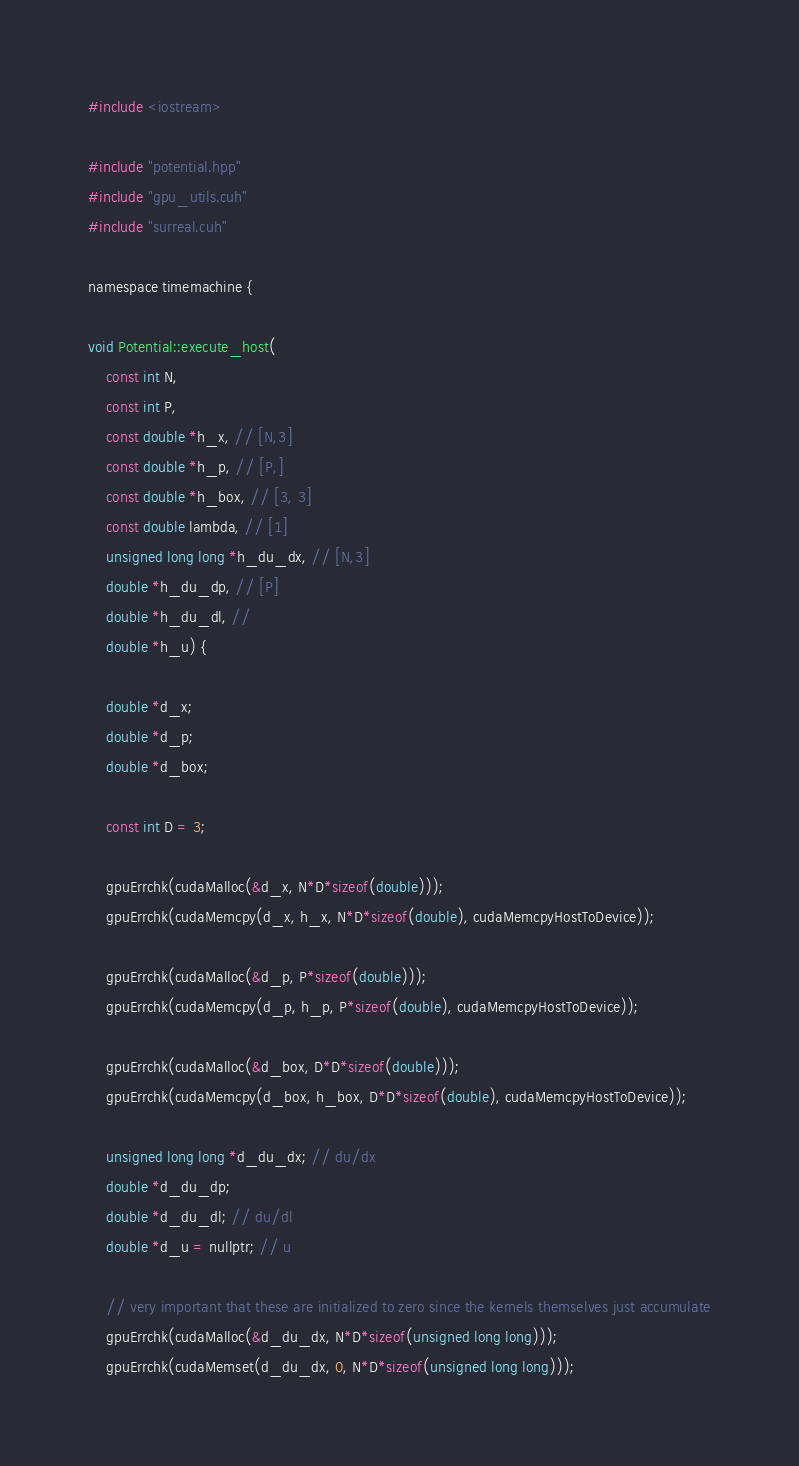<code> <loc_0><loc_0><loc_500><loc_500><_Cuda_>#include <iostream>

#include "potential.hpp"
#include "gpu_utils.cuh"
#include "surreal.cuh"

namespace timemachine {

void Potential::execute_host(
    const int N,
    const int P,
    const double *h_x, // [N,3]
    const double *h_p, // [P,]
    const double *h_box, // [3, 3]
    const double lambda, // [1]
    unsigned long long *h_du_dx, // [N,3]
    double *h_du_dp, // [P]
    double *h_du_dl, //
    double *h_u) {

    double *d_x;
    double *d_p;
    double *d_box;

    const int D = 3;

    gpuErrchk(cudaMalloc(&d_x, N*D*sizeof(double)));
    gpuErrchk(cudaMemcpy(d_x, h_x, N*D*sizeof(double), cudaMemcpyHostToDevice));

    gpuErrchk(cudaMalloc(&d_p, P*sizeof(double)));
    gpuErrchk(cudaMemcpy(d_p, h_p, P*sizeof(double), cudaMemcpyHostToDevice));

    gpuErrchk(cudaMalloc(&d_box, D*D*sizeof(double)));
    gpuErrchk(cudaMemcpy(d_box, h_box, D*D*sizeof(double), cudaMemcpyHostToDevice));

    unsigned long long *d_du_dx; // du/dx
    double *d_du_dp;
    double *d_du_dl; // du/dl
    double *d_u = nullptr; // u

    // very important that these are initialized to zero since the kernels themselves just accumulate
    gpuErrchk(cudaMalloc(&d_du_dx, N*D*sizeof(unsigned long long)));
    gpuErrchk(cudaMemset(d_du_dx, 0, N*D*sizeof(unsigned long long)));</code> 